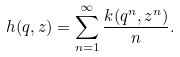Convert formula to latex. <formula><loc_0><loc_0><loc_500><loc_500>h ( q , z ) = \sum _ { n = 1 } ^ { \infty } \frac { k ( q ^ { n } , z ^ { n } ) } { n } .</formula> 